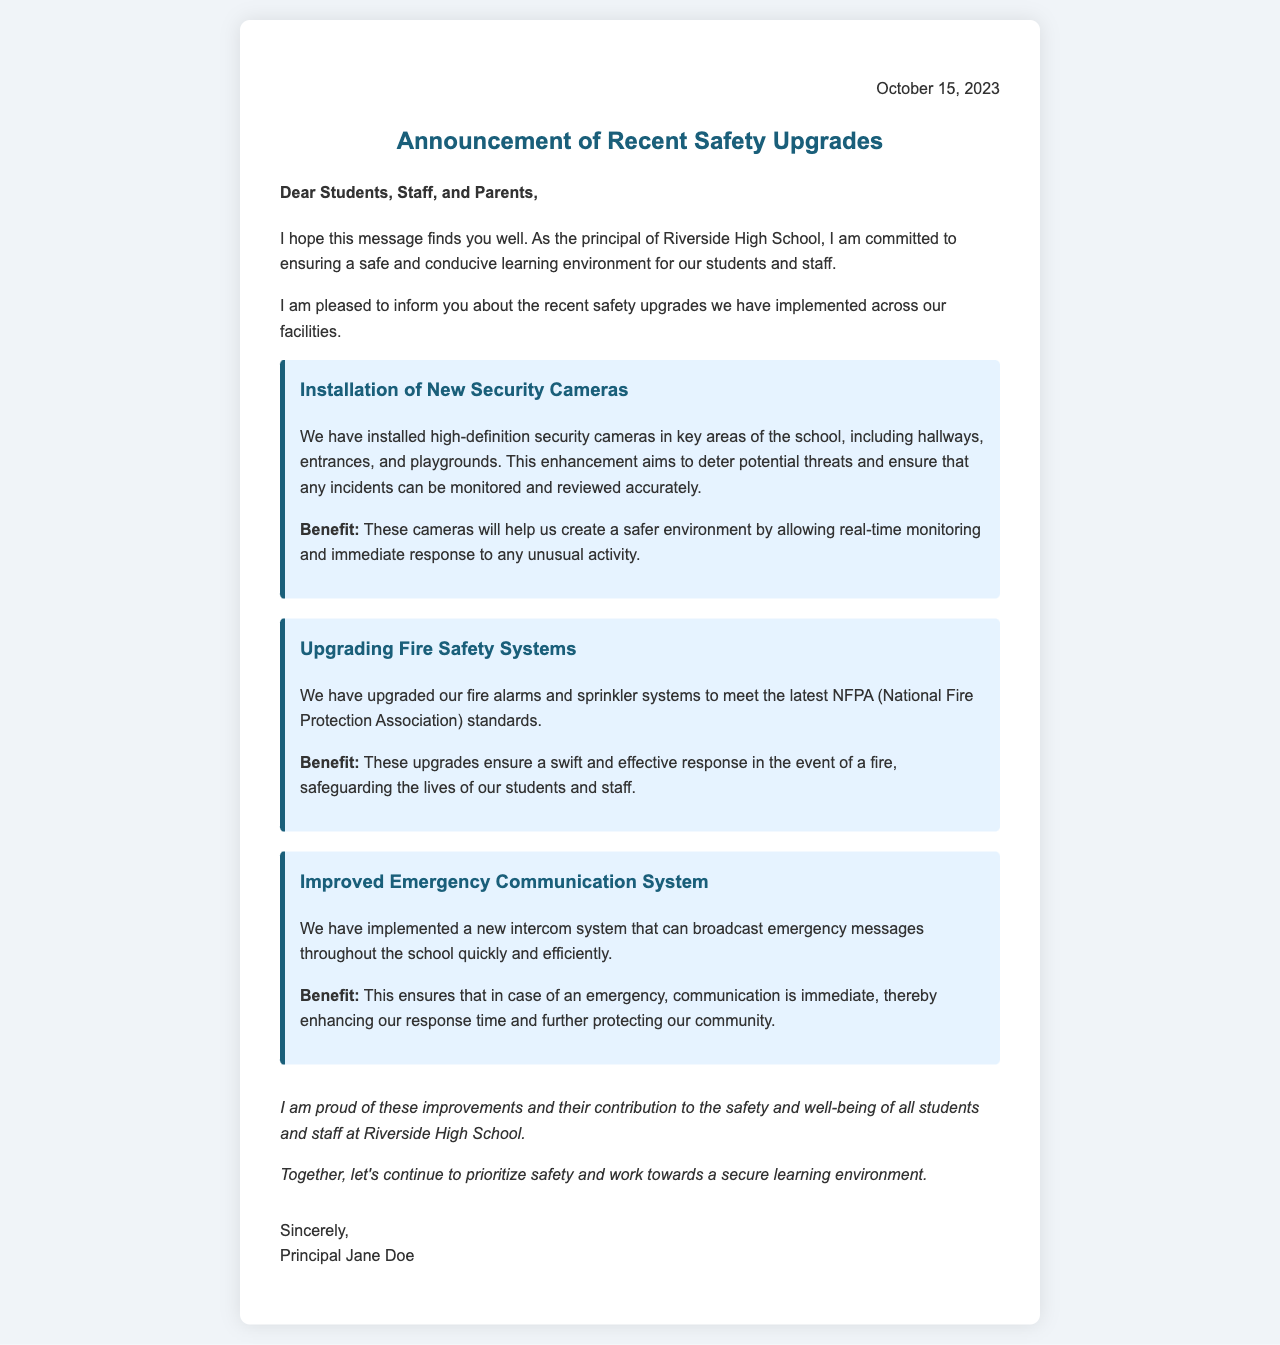What is the date of the letter? The date of the letter is stated in the header section as October 15, 2023.
Answer: October 15, 2023 Who is the principal signing the letter? The letter is signed by Principal Jane Doe, mentioned at the end as the signature.
Answer: Principal Jane Doe What is one of the safety upgrades mentioned in the letter? The letter lists several upgrades, one of which is the installation of new security cameras.
Answer: Installation of New Security Cameras What is the purpose of the upgraded fire safety systems? The document states that the upgraded fire safety systems ensure a swift and effective response in the event of a fire.
Answer: Safeguarding lives What benefit does the new intercom system provide? The letter explains that the new intercom system allows for immediate communication during emergencies, enhancing response time.
Answer: Immediate communication during emergencies How many types of upgrades are mentioned in the document? Three types of upgrades are detailed in the document: security cameras, fire safety systems, and emergency communication systems.
Answer: Three What does the principal express pride in? The principal expresses pride in the improvements made to safety and their contribution to well-being at the school.
Answer: Improvements and contribution to safety What is the focus of the letter? The letter focuses on communicating the completion of recent safety upgrades and their benefits.
Answer: Safety upgrades and benefits 